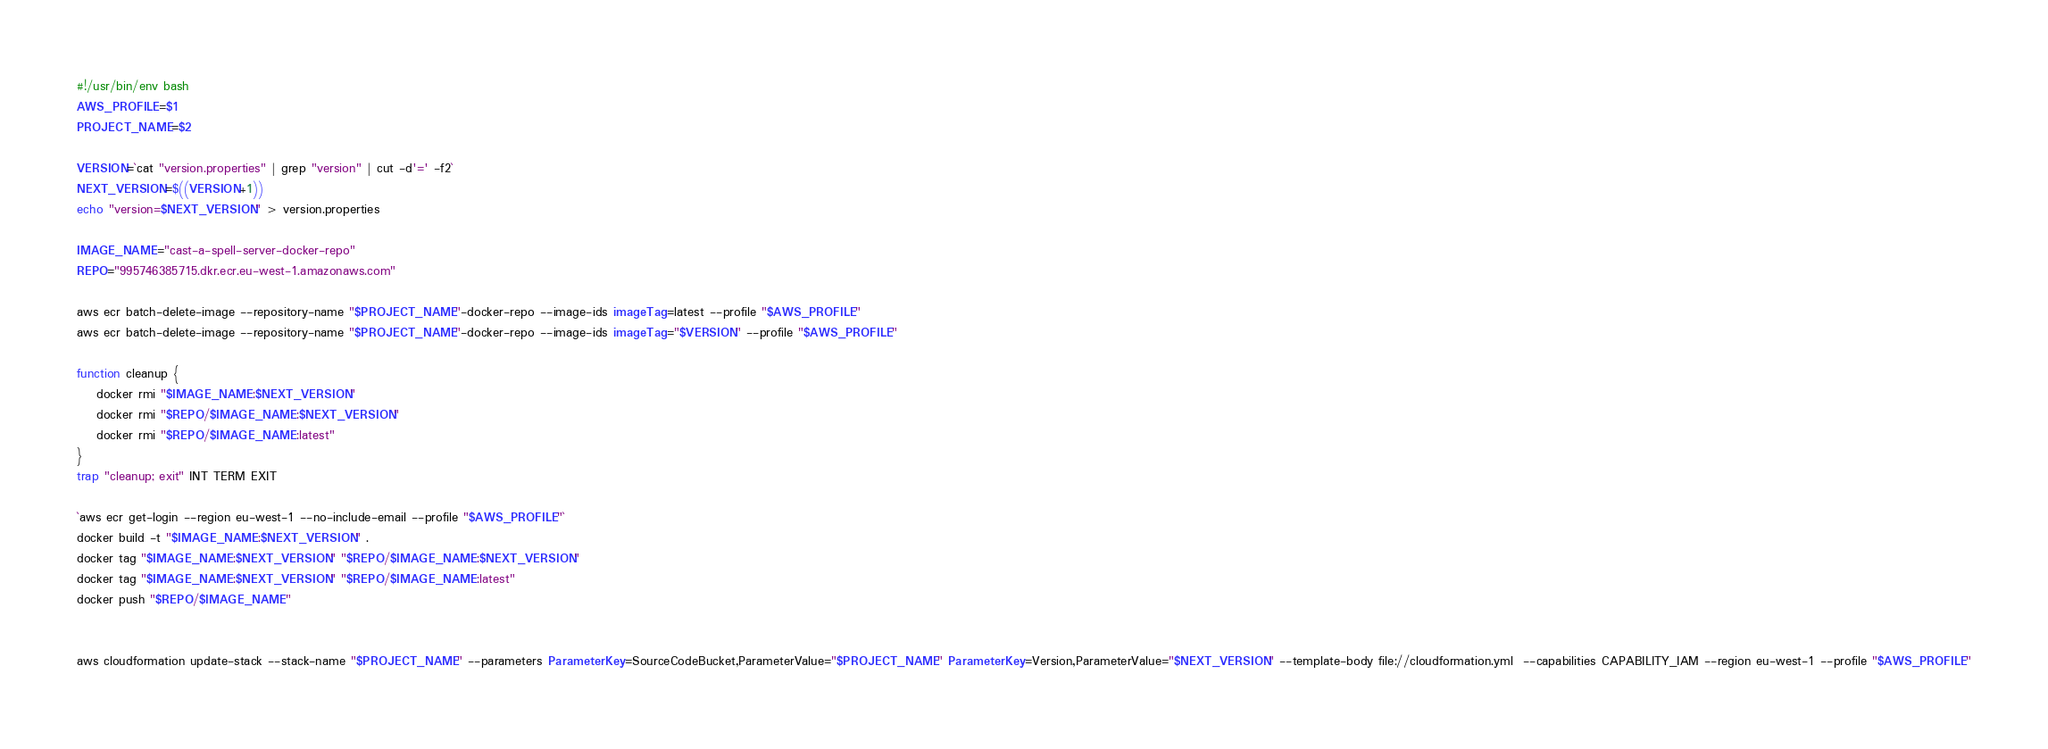<code> <loc_0><loc_0><loc_500><loc_500><_Bash_>#!/usr/bin/env bash
AWS_PROFILE=$1
PROJECT_NAME=$2

VERSION=`cat "version.properties" | grep "version" | cut -d'=' -f2`
NEXT_VERSION=$((VERSION+1))
echo "version=$NEXT_VERSION" > version.properties

IMAGE_NAME="cast-a-spell-server-docker-repo"
REPO="995746385715.dkr.ecr.eu-west-1.amazonaws.com"

aws ecr batch-delete-image --repository-name "$PROJECT_NAME"-docker-repo --image-ids imageTag=latest --profile "$AWS_PROFILE"
aws ecr batch-delete-image --repository-name "$PROJECT_NAME"-docker-repo --image-ids imageTag="$VERSION" --profile "$AWS_PROFILE"

function cleanup {
    docker rmi "$IMAGE_NAME:$NEXT_VERSION"
    docker rmi "$REPO/$IMAGE_NAME:$NEXT_VERSION"
    docker rmi "$REPO/$IMAGE_NAME:latest"
}
trap "cleanup; exit" INT TERM EXIT

`aws ecr get-login --region eu-west-1 --no-include-email --profile "$AWS_PROFILE"`
docker build -t "$IMAGE_NAME:$NEXT_VERSION" .
docker tag "$IMAGE_NAME:$NEXT_VERSION" "$REPO/$IMAGE_NAME:$NEXT_VERSION"
docker tag "$IMAGE_NAME:$NEXT_VERSION" "$REPO/$IMAGE_NAME:latest"
docker push "$REPO/$IMAGE_NAME"


aws cloudformation update-stack --stack-name "$PROJECT_NAME" --parameters ParameterKey=SourceCodeBucket,ParameterValue="$PROJECT_NAME" ParameterKey=Version,ParameterValue="$NEXT_VERSION" --template-body file://cloudformation.yml  --capabilities CAPABILITY_IAM --region eu-west-1 --profile "$AWS_PROFILE"

</code> 